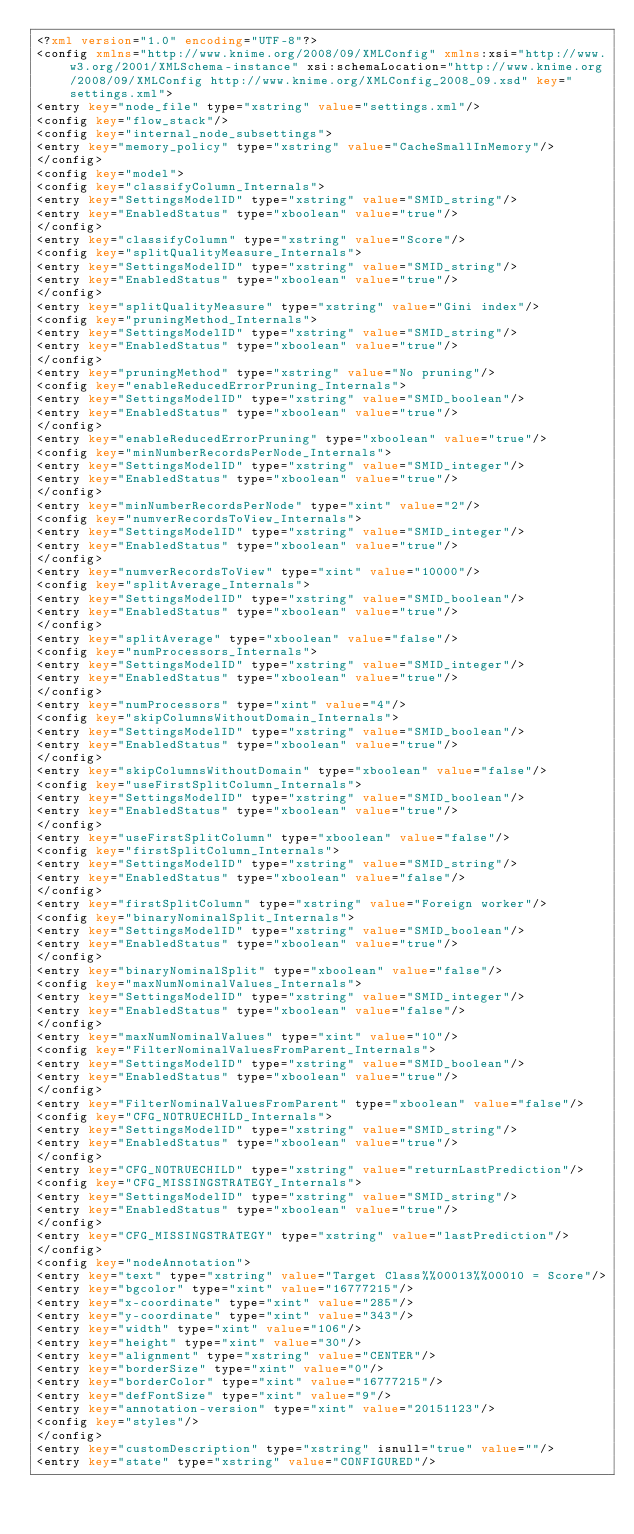Convert code to text. <code><loc_0><loc_0><loc_500><loc_500><_XML_><?xml version="1.0" encoding="UTF-8"?>
<config xmlns="http://www.knime.org/2008/09/XMLConfig" xmlns:xsi="http://www.w3.org/2001/XMLSchema-instance" xsi:schemaLocation="http://www.knime.org/2008/09/XMLConfig http://www.knime.org/XMLConfig_2008_09.xsd" key="settings.xml">
<entry key="node_file" type="xstring" value="settings.xml"/>
<config key="flow_stack"/>
<config key="internal_node_subsettings">
<entry key="memory_policy" type="xstring" value="CacheSmallInMemory"/>
</config>
<config key="model">
<config key="classifyColumn_Internals">
<entry key="SettingsModelID" type="xstring" value="SMID_string"/>
<entry key="EnabledStatus" type="xboolean" value="true"/>
</config>
<entry key="classifyColumn" type="xstring" value="Score"/>
<config key="splitQualityMeasure_Internals">
<entry key="SettingsModelID" type="xstring" value="SMID_string"/>
<entry key="EnabledStatus" type="xboolean" value="true"/>
</config>
<entry key="splitQualityMeasure" type="xstring" value="Gini index"/>
<config key="pruningMethod_Internals">
<entry key="SettingsModelID" type="xstring" value="SMID_string"/>
<entry key="EnabledStatus" type="xboolean" value="true"/>
</config>
<entry key="pruningMethod" type="xstring" value="No pruning"/>
<config key="enableReducedErrorPruning_Internals">
<entry key="SettingsModelID" type="xstring" value="SMID_boolean"/>
<entry key="EnabledStatus" type="xboolean" value="true"/>
</config>
<entry key="enableReducedErrorPruning" type="xboolean" value="true"/>
<config key="minNumberRecordsPerNode_Internals">
<entry key="SettingsModelID" type="xstring" value="SMID_integer"/>
<entry key="EnabledStatus" type="xboolean" value="true"/>
</config>
<entry key="minNumberRecordsPerNode" type="xint" value="2"/>
<config key="numverRecordsToView_Internals">
<entry key="SettingsModelID" type="xstring" value="SMID_integer"/>
<entry key="EnabledStatus" type="xboolean" value="true"/>
</config>
<entry key="numverRecordsToView" type="xint" value="10000"/>
<config key="splitAverage_Internals">
<entry key="SettingsModelID" type="xstring" value="SMID_boolean"/>
<entry key="EnabledStatus" type="xboolean" value="true"/>
</config>
<entry key="splitAverage" type="xboolean" value="false"/>
<config key="numProcessors_Internals">
<entry key="SettingsModelID" type="xstring" value="SMID_integer"/>
<entry key="EnabledStatus" type="xboolean" value="true"/>
</config>
<entry key="numProcessors" type="xint" value="4"/>
<config key="skipColumnsWithoutDomain_Internals">
<entry key="SettingsModelID" type="xstring" value="SMID_boolean"/>
<entry key="EnabledStatus" type="xboolean" value="true"/>
</config>
<entry key="skipColumnsWithoutDomain" type="xboolean" value="false"/>
<config key="useFirstSplitColumn_Internals">
<entry key="SettingsModelID" type="xstring" value="SMID_boolean"/>
<entry key="EnabledStatus" type="xboolean" value="true"/>
</config>
<entry key="useFirstSplitColumn" type="xboolean" value="false"/>
<config key="firstSplitColumn_Internals">
<entry key="SettingsModelID" type="xstring" value="SMID_string"/>
<entry key="EnabledStatus" type="xboolean" value="false"/>
</config>
<entry key="firstSplitColumn" type="xstring" value="Foreign worker"/>
<config key="binaryNominalSplit_Internals">
<entry key="SettingsModelID" type="xstring" value="SMID_boolean"/>
<entry key="EnabledStatus" type="xboolean" value="true"/>
</config>
<entry key="binaryNominalSplit" type="xboolean" value="false"/>
<config key="maxNumNominalValues_Internals">
<entry key="SettingsModelID" type="xstring" value="SMID_integer"/>
<entry key="EnabledStatus" type="xboolean" value="false"/>
</config>
<entry key="maxNumNominalValues" type="xint" value="10"/>
<config key="FilterNominalValuesFromParent_Internals">
<entry key="SettingsModelID" type="xstring" value="SMID_boolean"/>
<entry key="EnabledStatus" type="xboolean" value="true"/>
</config>
<entry key="FilterNominalValuesFromParent" type="xboolean" value="false"/>
<config key="CFG_NOTRUECHILD_Internals">
<entry key="SettingsModelID" type="xstring" value="SMID_string"/>
<entry key="EnabledStatus" type="xboolean" value="true"/>
</config>
<entry key="CFG_NOTRUECHILD" type="xstring" value="returnLastPrediction"/>
<config key="CFG_MISSINGSTRATEGY_Internals">
<entry key="SettingsModelID" type="xstring" value="SMID_string"/>
<entry key="EnabledStatus" type="xboolean" value="true"/>
</config>
<entry key="CFG_MISSINGSTRATEGY" type="xstring" value="lastPrediction"/>
</config>
<config key="nodeAnnotation">
<entry key="text" type="xstring" value="Target Class%%00013%%00010 = Score"/>
<entry key="bgcolor" type="xint" value="16777215"/>
<entry key="x-coordinate" type="xint" value="285"/>
<entry key="y-coordinate" type="xint" value="343"/>
<entry key="width" type="xint" value="106"/>
<entry key="height" type="xint" value="30"/>
<entry key="alignment" type="xstring" value="CENTER"/>
<entry key="borderSize" type="xint" value="0"/>
<entry key="borderColor" type="xint" value="16777215"/>
<entry key="defFontSize" type="xint" value="9"/>
<entry key="annotation-version" type="xint" value="20151123"/>
<config key="styles"/>
</config>
<entry key="customDescription" type="xstring" isnull="true" value=""/>
<entry key="state" type="xstring" value="CONFIGURED"/></code> 